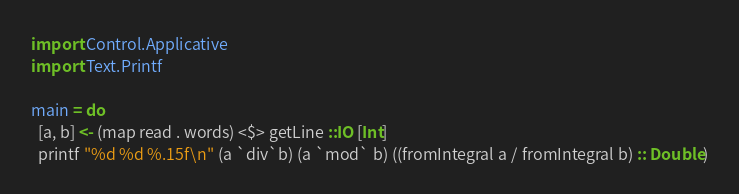Convert code to text. <code><loc_0><loc_0><loc_500><loc_500><_Haskell_>
import Control.Applicative
import Text.Printf

main = do
  [a, b] <- (map read . words) <$> getLine ::IO [Int]
  printf "%d %d %.15f\n" (a `div`b) (a `mod` b) ((fromIntegral a / fromIntegral b) :: Double)</code> 